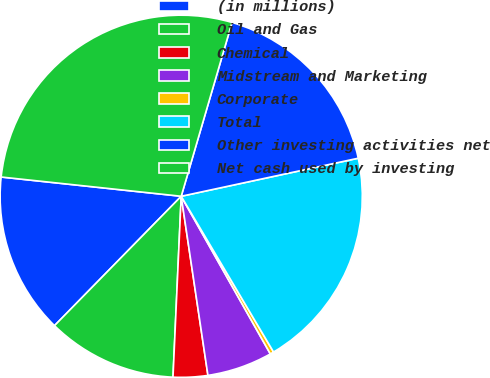Convert chart to OTSL. <chart><loc_0><loc_0><loc_500><loc_500><pie_chart><fcel>(in millions)<fcel>Oil and Gas<fcel>Chemical<fcel>Midstream and Marketing<fcel>Corporate<fcel>Total<fcel>Other investing activities net<fcel>Net cash used by investing<nl><fcel>14.36%<fcel>11.61%<fcel>3.08%<fcel>5.83%<fcel>0.33%<fcel>19.85%<fcel>17.1%<fcel>27.83%<nl></chart> 